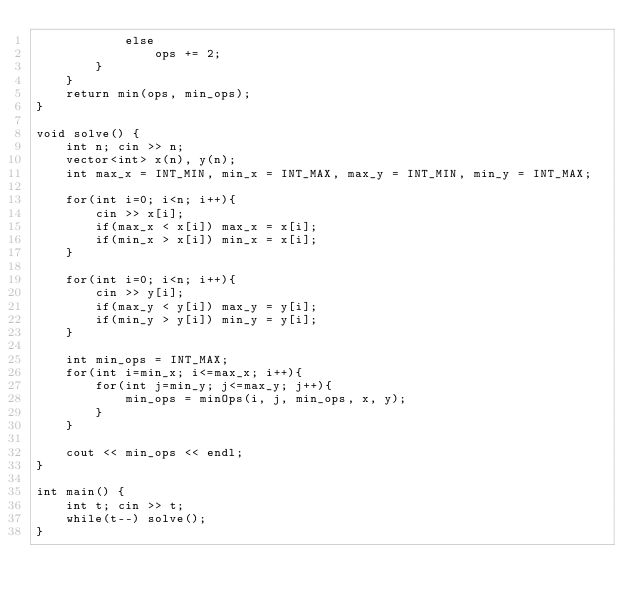Convert code to text. <code><loc_0><loc_0><loc_500><loc_500><_C++_>            else 
                ops += 2;
        }
    }
    return min(ops, min_ops);
}

void solve() {
    int n; cin >> n;
    vector<int> x(n), y(n);
    int max_x = INT_MIN, min_x = INT_MAX, max_y = INT_MIN, min_y = INT_MAX;
    
    for(int i=0; i<n; i++){
        cin >> x[i];
        if(max_x < x[i]) max_x = x[i];
        if(min_x > x[i]) min_x = x[i];
    }

    for(int i=0; i<n; i++){
        cin >> y[i];
        if(max_y < y[i]) max_y = y[i];
        if(min_y > y[i]) min_y = y[i];
    }

    int min_ops = INT_MAX;
    for(int i=min_x; i<=max_x; i++){
        for(int j=min_y; j<=max_y; j++){
            min_ops = minOps(i, j, min_ops, x, y);
        }
    }

    cout << min_ops << endl;
}

int main() {
    int t; cin >> t;
    while(t--) solve(); 
}
</code> 